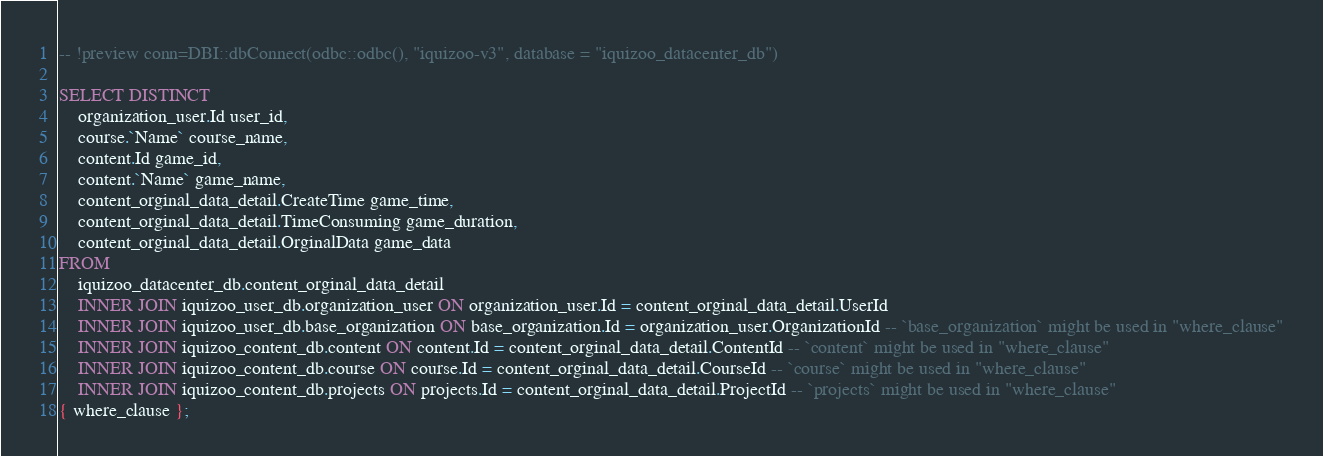Convert code to text. <code><loc_0><loc_0><loc_500><loc_500><_SQL_>-- !preview conn=DBI::dbConnect(odbc::odbc(), "iquizoo-v3", database = "iquizoo_datacenter_db")

SELECT DISTINCT
	organization_user.Id user_id,
	course.`Name` course_name,
	content.Id game_id,
	content.`Name` game_name,
	content_orginal_data_detail.CreateTime game_time,
	content_orginal_data_detail.TimeConsuming game_duration,
	content_orginal_data_detail.OrginalData game_data
FROM
	iquizoo_datacenter_db.content_orginal_data_detail
	INNER JOIN iquizoo_user_db.organization_user ON organization_user.Id = content_orginal_data_detail.UserId
	INNER JOIN iquizoo_user_db.base_organization ON base_organization.Id = organization_user.OrganizationId -- `base_organization` might be used in "where_clause"
	INNER JOIN iquizoo_content_db.content ON content.Id = content_orginal_data_detail.ContentId -- `content` might be used in "where_clause"
	INNER JOIN iquizoo_content_db.course ON course.Id = content_orginal_data_detail.CourseId -- `course` might be used in "where_clause"
	INNER JOIN iquizoo_content_db.projects ON projects.Id = content_orginal_data_detail.ProjectId -- `projects` might be used in "where_clause"
{ where_clause };
</code> 